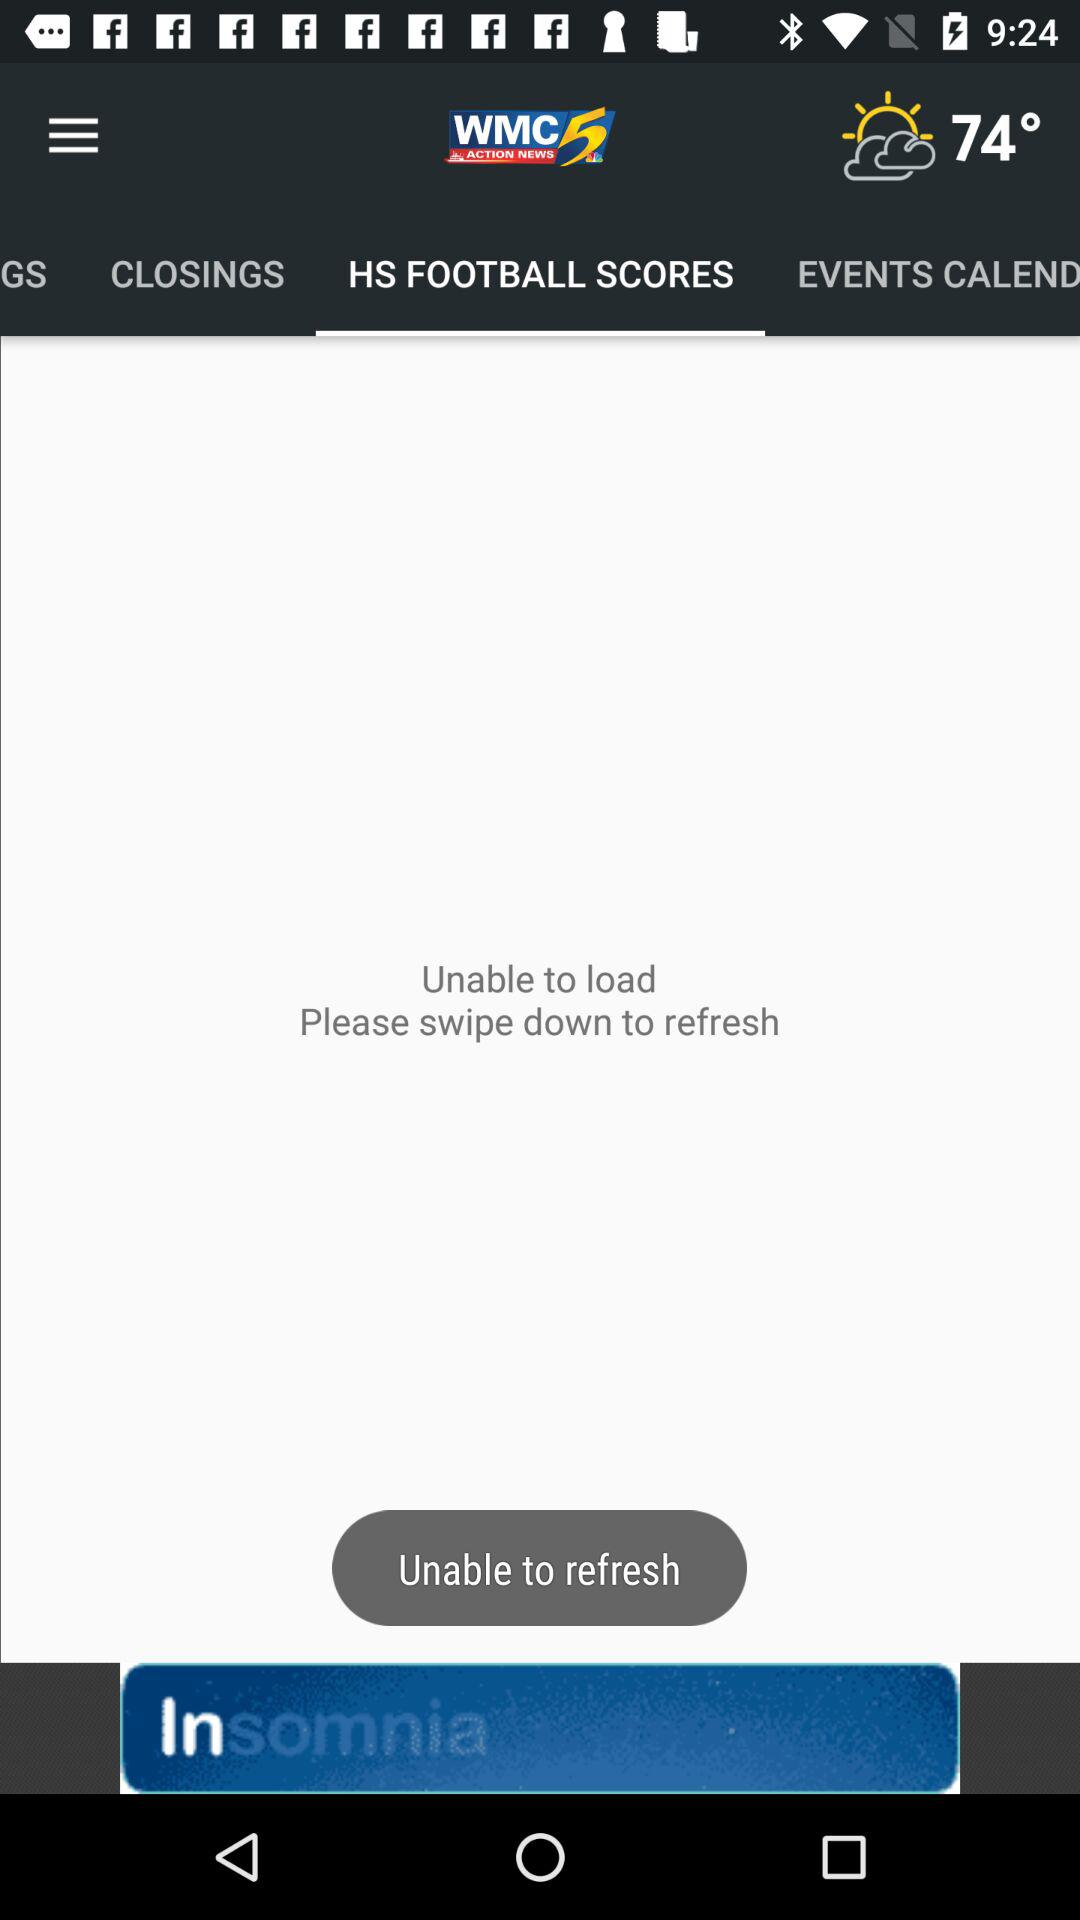Which tab is selected? The selected tab is "HS FOOTBALL SCORES". 